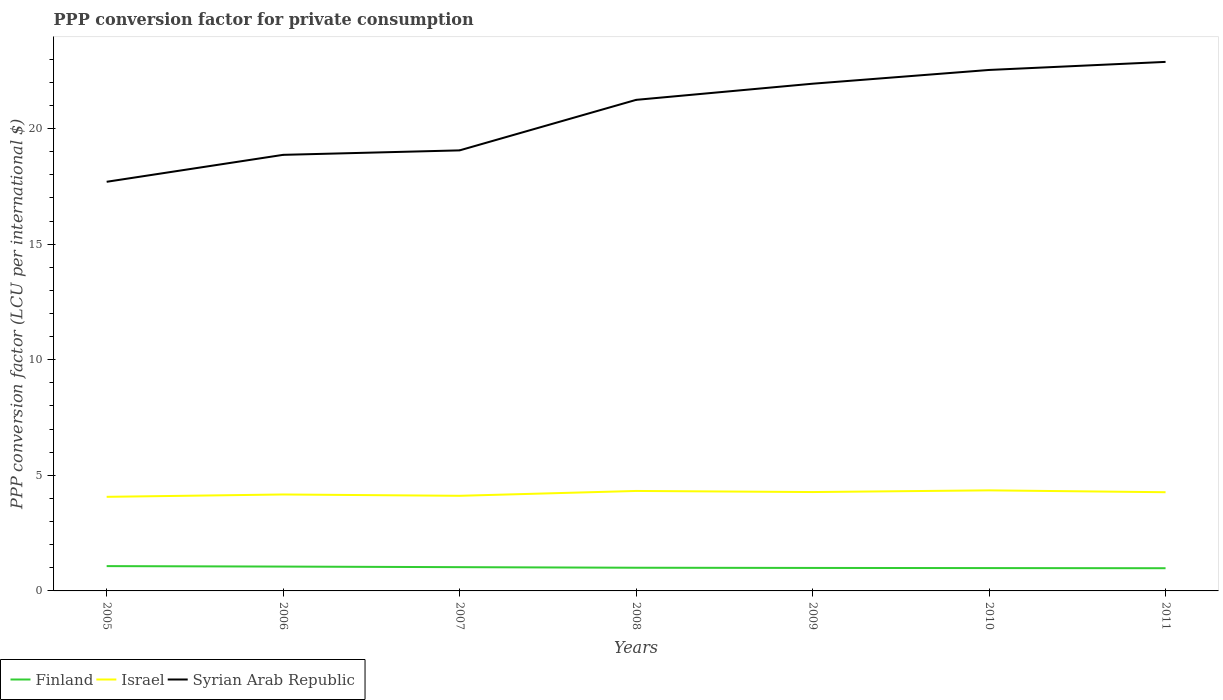Is the number of lines equal to the number of legend labels?
Your response must be concise. Yes. Across all years, what is the maximum PPP conversion factor for private consumption in Israel?
Offer a terse response. 4.07. What is the total PPP conversion factor for private consumption in Syrian Arab Republic in the graph?
Offer a terse response. -4.84. What is the difference between the highest and the second highest PPP conversion factor for private consumption in Israel?
Give a very brief answer. 0.28. How many lines are there?
Provide a succinct answer. 3. How many years are there in the graph?
Provide a succinct answer. 7. Does the graph contain any zero values?
Your answer should be very brief. No. How are the legend labels stacked?
Your answer should be very brief. Horizontal. What is the title of the graph?
Offer a very short reply. PPP conversion factor for private consumption. Does "Antigua and Barbuda" appear as one of the legend labels in the graph?
Give a very brief answer. No. What is the label or title of the X-axis?
Give a very brief answer. Years. What is the label or title of the Y-axis?
Provide a succinct answer. PPP conversion factor (LCU per international $). What is the PPP conversion factor (LCU per international $) in Finland in 2005?
Your response must be concise. 1.07. What is the PPP conversion factor (LCU per international $) of Israel in 2005?
Give a very brief answer. 4.07. What is the PPP conversion factor (LCU per international $) in Syrian Arab Republic in 2005?
Keep it short and to the point. 17.7. What is the PPP conversion factor (LCU per international $) in Finland in 2006?
Your response must be concise. 1.05. What is the PPP conversion factor (LCU per international $) in Israel in 2006?
Give a very brief answer. 4.17. What is the PPP conversion factor (LCU per international $) in Syrian Arab Republic in 2006?
Make the answer very short. 18.87. What is the PPP conversion factor (LCU per international $) of Finland in 2007?
Make the answer very short. 1.03. What is the PPP conversion factor (LCU per international $) of Israel in 2007?
Offer a terse response. 4.12. What is the PPP conversion factor (LCU per international $) of Syrian Arab Republic in 2007?
Provide a succinct answer. 19.06. What is the PPP conversion factor (LCU per international $) of Finland in 2008?
Keep it short and to the point. 1. What is the PPP conversion factor (LCU per international $) in Israel in 2008?
Your answer should be compact. 4.32. What is the PPP conversion factor (LCU per international $) of Syrian Arab Republic in 2008?
Provide a succinct answer. 21.24. What is the PPP conversion factor (LCU per international $) in Finland in 2009?
Provide a succinct answer. 0.99. What is the PPP conversion factor (LCU per international $) in Israel in 2009?
Offer a very short reply. 4.28. What is the PPP conversion factor (LCU per international $) in Syrian Arab Republic in 2009?
Provide a succinct answer. 21.94. What is the PPP conversion factor (LCU per international $) in Finland in 2010?
Ensure brevity in your answer.  0.99. What is the PPP conversion factor (LCU per international $) in Israel in 2010?
Provide a short and direct response. 4.35. What is the PPP conversion factor (LCU per international $) of Syrian Arab Republic in 2010?
Ensure brevity in your answer.  22.54. What is the PPP conversion factor (LCU per international $) in Finland in 2011?
Give a very brief answer. 0.98. What is the PPP conversion factor (LCU per international $) of Israel in 2011?
Offer a terse response. 4.27. What is the PPP conversion factor (LCU per international $) of Syrian Arab Republic in 2011?
Your answer should be very brief. 22.89. Across all years, what is the maximum PPP conversion factor (LCU per international $) in Finland?
Ensure brevity in your answer.  1.07. Across all years, what is the maximum PPP conversion factor (LCU per international $) in Israel?
Offer a terse response. 4.35. Across all years, what is the maximum PPP conversion factor (LCU per international $) in Syrian Arab Republic?
Your answer should be compact. 22.89. Across all years, what is the minimum PPP conversion factor (LCU per international $) in Finland?
Your response must be concise. 0.98. Across all years, what is the minimum PPP conversion factor (LCU per international $) in Israel?
Ensure brevity in your answer.  4.07. Across all years, what is the minimum PPP conversion factor (LCU per international $) of Syrian Arab Republic?
Keep it short and to the point. 17.7. What is the total PPP conversion factor (LCU per international $) of Finland in the graph?
Your answer should be compact. 7.12. What is the total PPP conversion factor (LCU per international $) in Israel in the graph?
Keep it short and to the point. 29.58. What is the total PPP conversion factor (LCU per international $) of Syrian Arab Republic in the graph?
Offer a terse response. 144.23. What is the difference between the PPP conversion factor (LCU per international $) in Finland in 2005 and that in 2006?
Provide a succinct answer. 0.02. What is the difference between the PPP conversion factor (LCU per international $) of Israel in 2005 and that in 2006?
Make the answer very short. -0.1. What is the difference between the PPP conversion factor (LCU per international $) in Syrian Arab Republic in 2005 and that in 2006?
Ensure brevity in your answer.  -1.17. What is the difference between the PPP conversion factor (LCU per international $) of Finland in 2005 and that in 2007?
Provide a succinct answer. 0.05. What is the difference between the PPP conversion factor (LCU per international $) in Israel in 2005 and that in 2007?
Give a very brief answer. -0.04. What is the difference between the PPP conversion factor (LCU per international $) in Syrian Arab Republic in 2005 and that in 2007?
Ensure brevity in your answer.  -1.36. What is the difference between the PPP conversion factor (LCU per international $) of Finland in 2005 and that in 2008?
Provide a short and direct response. 0.07. What is the difference between the PPP conversion factor (LCU per international $) of Israel in 2005 and that in 2008?
Give a very brief answer. -0.25. What is the difference between the PPP conversion factor (LCU per international $) of Syrian Arab Republic in 2005 and that in 2008?
Offer a terse response. -3.54. What is the difference between the PPP conversion factor (LCU per international $) of Finland in 2005 and that in 2009?
Provide a succinct answer. 0.08. What is the difference between the PPP conversion factor (LCU per international $) in Israel in 2005 and that in 2009?
Keep it short and to the point. -0.21. What is the difference between the PPP conversion factor (LCU per international $) of Syrian Arab Republic in 2005 and that in 2009?
Provide a short and direct response. -4.24. What is the difference between the PPP conversion factor (LCU per international $) of Finland in 2005 and that in 2010?
Offer a terse response. 0.09. What is the difference between the PPP conversion factor (LCU per international $) of Israel in 2005 and that in 2010?
Ensure brevity in your answer.  -0.28. What is the difference between the PPP conversion factor (LCU per international $) of Syrian Arab Republic in 2005 and that in 2010?
Your answer should be very brief. -4.84. What is the difference between the PPP conversion factor (LCU per international $) in Finland in 2005 and that in 2011?
Your answer should be compact. 0.09. What is the difference between the PPP conversion factor (LCU per international $) of Israel in 2005 and that in 2011?
Make the answer very short. -0.2. What is the difference between the PPP conversion factor (LCU per international $) of Syrian Arab Republic in 2005 and that in 2011?
Make the answer very short. -5.19. What is the difference between the PPP conversion factor (LCU per international $) of Finland in 2006 and that in 2007?
Ensure brevity in your answer.  0.03. What is the difference between the PPP conversion factor (LCU per international $) in Israel in 2006 and that in 2007?
Your answer should be very brief. 0.06. What is the difference between the PPP conversion factor (LCU per international $) of Syrian Arab Republic in 2006 and that in 2007?
Offer a very short reply. -0.19. What is the difference between the PPP conversion factor (LCU per international $) of Finland in 2006 and that in 2008?
Ensure brevity in your answer.  0.05. What is the difference between the PPP conversion factor (LCU per international $) of Israel in 2006 and that in 2008?
Your response must be concise. -0.15. What is the difference between the PPP conversion factor (LCU per international $) in Syrian Arab Republic in 2006 and that in 2008?
Give a very brief answer. -2.38. What is the difference between the PPP conversion factor (LCU per international $) of Finland in 2006 and that in 2009?
Make the answer very short. 0.06. What is the difference between the PPP conversion factor (LCU per international $) in Israel in 2006 and that in 2009?
Offer a very short reply. -0.1. What is the difference between the PPP conversion factor (LCU per international $) of Syrian Arab Republic in 2006 and that in 2009?
Make the answer very short. -3.08. What is the difference between the PPP conversion factor (LCU per international $) of Finland in 2006 and that in 2010?
Your answer should be compact. 0.07. What is the difference between the PPP conversion factor (LCU per international $) of Israel in 2006 and that in 2010?
Your answer should be very brief. -0.18. What is the difference between the PPP conversion factor (LCU per international $) of Syrian Arab Republic in 2006 and that in 2010?
Your answer should be compact. -3.67. What is the difference between the PPP conversion factor (LCU per international $) in Finland in 2006 and that in 2011?
Provide a succinct answer. 0.07. What is the difference between the PPP conversion factor (LCU per international $) in Israel in 2006 and that in 2011?
Offer a very short reply. -0.1. What is the difference between the PPP conversion factor (LCU per international $) of Syrian Arab Republic in 2006 and that in 2011?
Provide a succinct answer. -4.02. What is the difference between the PPP conversion factor (LCU per international $) in Finland in 2007 and that in 2008?
Give a very brief answer. 0.03. What is the difference between the PPP conversion factor (LCU per international $) in Israel in 2007 and that in 2008?
Keep it short and to the point. -0.21. What is the difference between the PPP conversion factor (LCU per international $) in Syrian Arab Republic in 2007 and that in 2008?
Your answer should be compact. -2.19. What is the difference between the PPP conversion factor (LCU per international $) of Finland in 2007 and that in 2009?
Offer a very short reply. 0.03. What is the difference between the PPP conversion factor (LCU per international $) in Israel in 2007 and that in 2009?
Your response must be concise. -0.16. What is the difference between the PPP conversion factor (LCU per international $) in Syrian Arab Republic in 2007 and that in 2009?
Ensure brevity in your answer.  -2.88. What is the difference between the PPP conversion factor (LCU per international $) in Finland in 2007 and that in 2010?
Your answer should be compact. 0.04. What is the difference between the PPP conversion factor (LCU per international $) in Israel in 2007 and that in 2010?
Offer a terse response. -0.24. What is the difference between the PPP conversion factor (LCU per international $) in Syrian Arab Republic in 2007 and that in 2010?
Your answer should be very brief. -3.48. What is the difference between the PPP conversion factor (LCU per international $) of Finland in 2007 and that in 2011?
Offer a terse response. 0.05. What is the difference between the PPP conversion factor (LCU per international $) of Israel in 2007 and that in 2011?
Your response must be concise. -0.16. What is the difference between the PPP conversion factor (LCU per international $) in Syrian Arab Republic in 2007 and that in 2011?
Offer a terse response. -3.83. What is the difference between the PPP conversion factor (LCU per international $) in Finland in 2008 and that in 2009?
Your response must be concise. 0.01. What is the difference between the PPP conversion factor (LCU per international $) of Israel in 2008 and that in 2009?
Give a very brief answer. 0.05. What is the difference between the PPP conversion factor (LCU per international $) of Syrian Arab Republic in 2008 and that in 2009?
Offer a very short reply. -0.7. What is the difference between the PPP conversion factor (LCU per international $) of Finland in 2008 and that in 2010?
Offer a very short reply. 0.01. What is the difference between the PPP conversion factor (LCU per international $) of Israel in 2008 and that in 2010?
Your answer should be compact. -0.03. What is the difference between the PPP conversion factor (LCU per international $) in Syrian Arab Republic in 2008 and that in 2010?
Offer a terse response. -1.29. What is the difference between the PPP conversion factor (LCU per international $) in Finland in 2008 and that in 2011?
Your answer should be very brief. 0.02. What is the difference between the PPP conversion factor (LCU per international $) of Israel in 2008 and that in 2011?
Your answer should be compact. 0.05. What is the difference between the PPP conversion factor (LCU per international $) in Syrian Arab Republic in 2008 and that in 2011?
Provide a succinct answer. -1.64. What is the difference between the PPP conversion factor (LCU per international $) of Finland in 2009 and that in 2010?
Make the answer very short. 0.01. What is the difference between the PPP conversion factor (LCU per international $) in Israel in 2009 and that in 2010?
Offer a very short reply. -0.07. What is the difference between the PPP conversion factor (LCU per international $) of Syrian Arab Republic in 2009 and that in 2010?
Your answer should be very brief. -0.6. What is the difference between the PPP conversion factor (LCU per international $) in Finland in 2009 and that in 2011?
Make the answer very short. 0.01. What is the difference between the PPP conversion factor (LCU per international $) in Israel in 2009 and that in 2011?
Offer a very short reply. 0.01. What is the difference between the PPP conversion factor (LCU per international $) of Syrian Arab Republic in 2009 and that in 2011?
Your response must be concise. -0.94. What is the difference between the PPP conversion factor (LCU per international $) in Finland in 2010 and that in 2011?
Provide a succinct answer. 0.01. What is the difference between the PPP conversion factor (LCU per international $) in Israel in 2010 and that in 2011?
Ensure brevity in your answer.  0.08. What is the difference between the PPP conversion factor (LCU per international $) of Syrian Arab Republic in 2010 and that in 2011?
Keep it short and to the point. -0.35. What is the difference between the PPP conversion factor (LCU per international $) of Finland in 2005 and the PPP conversion factor (LCU per international $) of Israel in 2006?
Give a very brief answer. -3.1. What is the difference between the PPP conversion factor (LCU per international $) in Finland in 2005 and the PPP conversion factor (LCU per international $) in Syrian Arab Republic in 2006?
Provide a short and direct response. -17.79. What is the difference between the PPP conversion factor (LCU per international $) in Israel in 2005 and the PPP conversion factor (LCU per international $) in Syrian Arab Republic in 2006?
Your answer should be very brief. -14.79. What is the difference between the PPP conversion factor (LCU per international $) of Finland in 2005 and the PPP conversion factor (LCU per international $) of Israel in 2007?
Give a very brief answer. -3.04. What is the difference between the PPP conversion factor (LCU per international $) in Finland in 2005 and the PPP conversion factor (LCU per international $) in Syrian Arab Republic in 2007?
Ensure brevity in your answer.  -17.99. What is the difference between the PPP conversion factor (LCU per international $) in Israel in 2005 and the PPP conversion factor (LCU per international $) in Syrian Arab Republic in 2007?
Your answer should be compact. -14.99. What is the difference between the PPP conversion factor (LCU per international $) of Finland in 2005 and the PPP conversion factor (LCU per international $) of Israel in 2008?
Your answer should be very brief. -3.25. What is the difference between the PPP conversion factor (LCU per international $) of Finland in 2005 and the PPP conversion factor (LCU per international $) of Syrian Arab Republic in 2008?
Your response must be concise. -20.17. What is the difference between the PPP conversion factor (LCU per international $) of Israel in 2005 and the PPP conversion factor (LCU per international $) of Syrian Arab Republic in 2008?
Ensure brevity in your answer.  -17.17. What is the difference between the PPP conversion factor (LCU per international $) in Finland in 2005 and the PPP conversion factor (LCU per international $) in Israel in 2009?
Provide a succinct answer. -3.2. What is the difference between the PPP conversion factor (LCU per international $) in Finland in 2005 and the PPP conversion factor (LCU per international $) in Syrian Arab Republic in 2009?
Your response must be concise. -20.87. What is the difference between the PPP conversion factor (LCU per international $) in Israel in 2005 and the PPP conversion factor (LCU per international $) in Syrian Arab Republic in 2009?
Give a very brief answer. -17.87. What is the difference between the PPP conversion factor (LCU per international $) in Finland in 2005 and the PPP conversion factor (LCU per international $) in Israel in 2010?
Ensure brevity in your answer.  -3.28. What is the difference between the PPP conversion factor (LCU per international $) in Finland in 2005 and the PPP conversion factor (LCU per international $) in Syrian Arab Republic in 2010?
Ensure brevity in your answer.  -21.46. What is the difference between the PPP conversion factor (LCU per international $) of Israel in 2005 and the PPP conversion factor (LCU per international $) of Syrian Arab Republic in 2010?
Keep it short and to the point. -18.47. What is the difference between the PPP conversion factor (LCU per international $) in Finland in 2005 and the PPP conversion factor (LCU per international $) in Israel in 2011?
Provide a succinct answer. -3.2. What is the difference between the PPP conversion factor (LCU per international $) of Finland in 2005 and the PPP conversion factor (LCU per international $) of Syrian Arab Republic in 2011?
Provide a succinct answer. -21.81. What is the difference between the PPP conversion factor (LCU per international $) of Israel in 2005 and the PPP conversion factor (LCU per international $) of Syrian Arab Republic in 2011?
Offer a terse response. -18.82. What is the difference between the PPP conversion factor (LCU per international $) in Finland in 2006 and the PPP conversion factor (LCU per international $) in Israel in 2007?
Give a very brief answer. -3.06. What is the difference between the PPP conversion factor (LCU per international $) of Finland in 2006 and the PPP conversion factor (LCU per international $) of Syrian Arab Republic in 2007?
Ensure brevity in your answer.  -18.01. What is the difference between the PPP conversion factor (LCU per international $) of Israel in 2006 and the PPP conversion factor (LCU per international $) of Syrian Arab Republic in 2007?
Give a very brief answer. -14.89. What is the difference between the PPP conversion factor (LCU per international $) in Finland in 2006 and the PPP conversion factor (LCU per international $) in Israel in 2008?
Keep it short and to the point. -3.27. What is the difference between the PPP conversion factor (LCU per international $) in Finland in 2006 and the PPP conversion factor (LCU per international $) in Syrian Arab Republic in 2008?
Provide a succinct answer. -20.19. What is the difference between the PPP conversion factor (LCU per international $) in Israel in 2006 and the PPP conversion factor (LCU per international $) in Syrian Arab Republic in 2008?
Offer a very short reply. -17.07. What is the difference between the PPP conversion factor (LCU per international $) in Finland in 2006 and the PPP conversion factor (LCU per international $) in Israel in 2009?
Keep it short and to the point. -3.22. What is the difference between the PPP conversion factor (LCU per international $) in Finland in 2006 and the PPP conversion factor (LCU per international $) in Syrian Arab Republic in 2009?
Offer a terse response. -20.89. What is the difference between the PPP conversion factor (LCU per international $) of Israel in 2006 and the PPP conversion factor (LCU per international $) of Syrian Arab Republic in 2009?
Make the answer very short. -17.77. What is the difference between the PPP conversion factor (LCU per international $) in Finland in 2006 and the PPP conversion factor (LCU per international $) in Israel in 2010?
Ensure brevity in your answer.  -3.3. What is the difference between the PPP conversion factor (LCU per international $) of Finland in 2006 and the PPP conversion factor (LCU per international $) of Syrian Arab Republic in 2010?
Keep it short and to the point. -21.48. What is the difference between the PPP conversion factor (LCU per international $) in Israel in 2006 and the PPP conversion factor (LCU per international $) in Syrian Arab Republic in 2010?
Provide a succinct answer. -18.37. What is the difference between the PPP conversion factor (LCU per international $) of Finland in 2006 and the PPP conversion factor (LCU per international $) of Israel in 2011?
Offer a very short reply. -3.22. What is the difference between the PPP conversion factor (LCU per international $) of Finland in 2006 and the PPP conversion factor (LCU per international $) of Syrian Arab Republic in 2011?
Ensure brevity in your answer.  -21.83. What is the difference between the PPP conversion factor (LCU per international $) in Israel in 2006 and the PPP conversion factor (LCU per international $) in Syrian Arab Republic in 2011?
Your answer should be compact. -18.71. What is the difference between the PPP conversion factor (LCU per international $) in Finland in 2007 and the PPP conversion factor (LCU per international $) in Israel in 2008?
Provide a succinct answer. -3.3. What is the difference between the PPP conversion factor (LCU per international $) in Finland in 2007 and the PPP conversion factor (LCU per international $) in Syrian Arab Republic in 2008?
Provide a short and direct response. -20.22. What is the difference between the PPP conversion factor (LCU per international $) in Israel in 2007 and the PPP conversion factor (LCU per international $) in Syrian Arab Republic in 2008?
Give a very brief answer. -17.13. What is the difference between the PPP conversion factor (LCU per international $) of Finland in 2007 and the PPP conversion factor (LCU per international $) of Israel in 2009?
Provide a short and direct response. -3.25. What is the difference between the PPP conversion factor (LCU per international $) in Finland in 2007 and the PPP conversion factor (LCU per international $) in Syrian Arab Republic in 2009?
Offer a very short reply. -20.91. What is the difference between the PPP conversion factor (LCU per international $) of Israel in 2007 and the PPP conversion factor (LCU per international $) of Syrian Arab Republic in 2009?
Keep it short and to the point. -17.83. What is the difference between the PPP conversion factor (LCU per international $) in Finland in 2007 and the PPP conversion factor (LCU per international $) in Israel in 2010?
Give a very brief answer. -3.32. What is the difference between the PPP conversion factor (LCU per international $) in Finland in 2007 and the PPP conversion factor (LCU per international $) in Syrian Arab Republic in 2010?
Keep it short and to the point. -21.51. What is the difference between the PPP conversion factor (LCU per international $) of Israel in 2007 and the PPP conversion factor (LCU per international $) of Syrian Arab Republic in 2010?
Offer a very short reply. -18.42. What is the difference between the PPP conversion factor (LCU per international $) in Finland in 2007 and the PPP conversion factor (LCU per international $) in Israel in 2011?
Provide a short and direct response. -3.24. What is the difference between the PPP conversion factor (LCU per international $) in Finland in 2007 and the PPP conversion factor (LCU per international $) in Syrian Arab Republic in 2011?
Your answer should be very brief. -21.86. What is the difference between the PPP conversion factor (LCU per international $) in Israel in 2007 and the PPP conversion factor (LCU per international $) in Syrian Arab Republic in 2011?
Offer a terse response. -18.77. What is the difference between the PPP conversion factor (LCU per international $) in Finland in 2008 and the PPP conversion factor (LCU per international $) in Israel in 2009?
Keep it short and to the point. -3.27. What is the difference between the PPP conversion factor (LCU per international $) of Finland in 2008 and the PPP conversion factor (LCU per international $) of Syrian Arab Republic in 2009?
Ensure brevity in your answer.  -20.94. What is the difference between the PPP conversion factor (LCU per international $) in Israel in 2008 and the PPP conversion factor (LCU per international $) in Syrian Arab Republic in 2009?
Provide a short and direct response. -17.62. What is the difference between the PPP conversion factor (LCU per international $) in Finland in 2008 and the PPP conversion factor (LCU per international $) in Israel in 2010?
Your response must be concise. -3.35. What is the difference between the PPP conversion factor (LCU per international $) in Finland in 2008 and the PPP conversion factor (LCU per international $) in Syrian Arab Republic in 2010?
Your answer should be very brief. -21.54. What is the difference between the PPP conversion factor (LCU per international $) in Israel in 2008 and the PPP conversion factor (LCU per international $) in Syrian Arab Republic in 2010?
Your answer should be compact. -18.21. What is the difference between the PPP conversion factor (LCU per international $) of Finland in 2008 and the PPP conversion factor (LCU per international $) of Israel in 2011?
Provide a succinct answer. -3.27. What is the difference between the PPP conversion factor (LCU per international $) in Finland in 2008 and the PPP conversion factor (LCU per international $) in Syrian Arab Republic in 2011?
Offer a very short reply. -21.88. What is the difference between the PPP conversion factor (LCU per international $) of Israel in 2008 and the PPP conversion factor (LCU per international $) of Syrian Arab Republic in 2011?
Your answer should be compact. -18.56. What is the difference between the PPP conversion factor (LCU per international $) of Finland in 2009 and the PPP conversion factor (LCU per international $) of Israel in 2010?
Ensure brevity in your answer.  -3.36. What is the difference between the PPP conversion factor (LCU per international $) in Finland in 2009 and the PPP conversion factor (LCU per international $) in Syrian Arab Republic in 2010?
Provide a succinct answer. -21.54. What is the difference between the PPP conversion factor (LCU per international $) of Israel in 2009 and the PPP conversion factor (LCU per international $) of Syrian Arab Republic in 2010?
Make the answer very short. -18.26. What is the difference between the PPP conversion factor (LCU per international $) of Finland in 2009 and the PPP conversion factor (LCU per international $) of Israel in 2011?
Offer a very short reply. -3.28. What is the difference between the PPP conversion factor (LCU per international $) in Finland in 2009 and the PPP conversion factor (LCU per international $) in Syrian Arab Republic in 2011?
Provide a short and direct response. -21.89. What is the difference between the PPP conversion factor (LCU per international $) of Israel in 2009 and the PPP conversion factor (LCU per international $) of Syrian Arab Republic in 2011?
Make the answer very short. -18.61. What is the difference between the PPP conversion factor (LCU per international $) of Finland in 2010 and the PPP conversion factor (LCU per international $) of Israel in 2011?
Your answer should be very brief. -3.28. What is the difference between the PPP conversion factor (LCU per international $) in Finland in 2010 and the PPP conversion factor (LCU per international $) in Syrian Arab Republic in 2011?
Your answer should be very brief. -21.9. What is the difference between the PPP conversion factor (LCU per international $) of Israel in 2010 and the PPP conversion factor (LCU per international $) of Syrian Arab Republic in 2011?
Give a very brief answer. -18.54. What is the average PPP conversion factor (LCU per international $) in Finland per year?
Provide a succinct answer. 1.02. What is the average PPP conversion factor (LCU per international $) in Israel per year?
Offer a very short reply. 4.23. What is the average PPP conversion factor (LCU per international $) in Syrian Arab Republic per year?
Provide a short and direct response. 20.6. In the year 2005, what is the difference between the PPP conversion factor (LCU per international $) in Finland and PPP conversion factor (LCU per international $) in Israel?
Keep it short and to the point. -3. In the year 2005, what is the difference between the PPP conversion factor (LCU per international $) in Finland and PPP conversion factor (LCU per international $) in Syrian Arab Republic?
Provide a short and direct response. -16.63. In the year 2005, what is the difference between the PPP conversion factor (LCU per international $) in Israel and PPP conversion factor (LCU per international $) in Syrian Arab Republic?
Offer a terse response. -13.63. In the year 2006, what is the difference between the PPP conversion factor (LCU per international $) in Finland and PPP conversion factor (LCU per international $) in Israel?
Ensure brevity in your answer.  -3.12. In the year 2006, what is the difference between the PPP conversion factor (LCU per international $) in Finland and PPP conversion factor (LCU per international $) in Syrian Arab Republic?
Make the answer very short. -17.81. In the year 2006, what is the difference between the PPP conversion factor (LCU per international $) of Israel and PPP conversion factor (LCU per international $) of Syrian Arab Republic?
Offer a very short reply. -14.69. In the year 2007, what is the difference between the PPP conversion factor (LCU per international $) in Finland and PPP conversion factor (LCU per international $) in Israel?
Make the answer very short. -3.09. In the year 2007, what is the difference between the PPP conversion factor (LCU per international $) of Finland and PPP conversion factor (LCU per international $) of Syrian Arab Republic?
Make the answer very short. -18.03. In the year 2007, what is the difference between the PPP conversion factor (LCU per international $) of Israel and PPP conversion factor (LCU per international $) of Syrian Arab Republic?
Give a very brief answer. -14.94. In the year 2008, what is the difference between the PPP conversion factor (LCU per international $) in Finland and PPP conversion factor (LCU per international $) in Israel?
Give a very brief answer. -3.32. In the year 2008, what is the difference between the PPP conversion factor (LCU per international $) of Finland and PPP conversion factor (LCU per international $) of Syrian Arab Republic?
Offer a very short reply. -20.24. In the year 2008, what is the difference between the PPP conversion factor (LCU per international $) in Israel and PPP conversion factor (LCU per international $) in Syrian Arab Republic?
Your answer should be compact. -16.92. In the year 2009, what is the difference between the PPP conversion factor (LCU per international $) in Finland and PPP conversion factor (LCU per international $) in Israel?
Ensure brevity in your answer.  -3.28. In the year 2009, what is the difference between the PPP conversion factor (LCU per international $) of Finland and PPP conversion factor (LCU per international $) of Syrian Arab Republic?
Offer a terse response. -20.95. In the year 2009, what is the difference between the PPP conversion factor (LCU per international $) of Israel and PPP conversion factor (LCU per international $) of Syrian Arab Republic?
Your answer should be compact. -17.67. In the year 2010, what is the difference between the PPP conversion factor (LCU per international $) in Finland and PPP conversion factor (LCU per international $) in Israel?
Your response must be concise. -3.36. In the year 2010, what is the difference between the PPP conversion factor (LCU per international $) in Finland and PPP conversion factor (LCU per international $) in Syrian Arab Republic?
Offer a terse response. -21.55. In the year 2010, what is the difference between the PPP conversion factor (LCU per international $) in Israel and PPP conversion factor (LCU per international $) in Syrian Arab Republic?
Provide a succinct answer. -18.19. In the year 2011, what is the difference between the PPP conversion factor (LCU per international $) in Finland and PPP conversion factor (LCU per international $) in Israel?
Your response must be concise. -3.29. In the year 2011, what is the difference between the PPP conversion factor (LCU per international $) of Finland and PPP conversion factor (LCU per international $) of Syrian Arab Republic?
Provide a succinct answer. -21.9. In the year 2011, what is the difference between the PPP conversion factor (LCU per international $) of Israel and PPP conversion factor (LCU per international $) of Syrian Arab Republic?
Your answer should be compact. -18.62. What is the ratio of the PPP conversion factor (LCU per international $) in Finland in 2005 to that in 2006?
Keep it short and to the point. 1.02. What is the ratio of the PPP conversion factor (LCU per international $) of Israel in 2005 to that in 2006?
Your answer should be very brief. 0.98. What is the ratio of the PPP conversion factor (LCU per international $) in Syrian Arab Republic in 2005 to that in 2006?
Ensure brevity in your answer.  0.94. What is the ratio of the PPP conversion factor (LCU per international $) of Finland in 2005 to that in 2007?
Make the answer very short. 1.04. What is the ratio of the PPP conversion factor (LCU per international $) in Israel in 2005 to that in 2007?
Provide a short and direct response. 0.99. What is the ratio of the PPP conversion factor (LCU per international $) in Syrian Arab Republic in 2005 to that in 2007?
Ensure brevity in your answer.  0.93. What is the ratio of the PPP conversion factor (LCU per international $) in Finland in 2005 to that in 2008?
Offer a terse response. 1.07. What is the ratio of the PPP conversion factor (LCU per international $) in Israel in 2005 to that in 2008?
Provide a succinct answer. 0.94. What is the ratio of the PPP conversion factor (LCU per international $) of Syrian Arab Republic in 2005 to that in 2008?
Your response must be concise. 0.83. What is the ratio of the PPP conversion factor (LCU per international $) in Finland in 2005 to that in 2009?
Provide a succinct answer. 1.08. What is the ratio of the PPP conversion factor (LCU per international $) of Israel in 2005 to that in 2009?
Give a very brief answer. 0.95. What is the ratio of the PPP conversion factor (LCU per international $) of Syrian Arab Republic in 2005 to that in 2009?
Offer a terse response. 0.81. What is the ratio of the PPP conversion factor (LCU per international $) of Finland in 2005 to that in 2010?
Provide a succinct answer. 1.09. What is the ratio of the PPP conversion factor (LCU per international $) in Israel in 2005 to that in 2010?
Your answer should be very brief. 0.94. What is the ratio of the PPP conversion factor (LCU per international $) of Syrian Arab Republic in 2005 to that in 2010?
Your answer should be very brief. 0.79. What is the ratio of the PPP conversion factor (LCU per international $) in Finland in 2005 to that in 2011?
Offer a very short reply. 1.09. What is the ratio of the PPP conversion factor (LCU per international $) of Israel in 2005 to that in 2011?
Offer a terse response. 0.95. What is the ratio of the PPP conversion factor (LCU per international $) in Syrian Arab Republic in 2005 to that in 2011?
Keep it short and to the point. 0.77. What is the ratio of the PPP conversion factor (LCU per international $) of Finland in 2006 to that in 2007?
Provide a succinct answer. 1.02. What is the ratio of the PPP conversion factor (LCU per international $) of Israel in 2006 to that in 2007?
Your answer should be very brief. 1.01. What is the ratio of the PPP conversion factor (LCU per international $) of Finland in 2006 to that in 2008?
Give a very brief answer. 1.05. What is the ratio of the PPP conversion factor (LCU per international $) in Israel in 2006 to that in 2008?
Provide a short and direct response. 0.96. What is the ratio of the PPP conversion factor (LCU per international $) in Syrian Arab Republic in 2006 to that in 2008?
Your answer should be compact. 0.89. What is the ratio of the PPP conversion factor (LCU per international $) of Finland in 2006 to that in 2009?
Offer a very short reply. 1.06. What is the ratio of the PPP conversion factor (LCU per international $) in Israel in 2006 to that in 2009?
Your response must be concise. 0.98. What is the ratio of the PPP conversion factor (LCU per international $) of Syrian Arab Republic in 2006 to that in 2009?
Provide a short and direct response. 0.86. What is the ratio of the PPP conversion factor (LCU per international $) of Finland in 2006 to that in 2010?
Provide a succinct answer. 1.07. What is the ratio of the PPP conversion factor (LCU per international $) of Israel in 2006 to that in 2010?
Ensure brevity in your answer.  0.96. What is the ratio of the PPP conversion factor (LCU per international $) of Syrian Arab Republic in 2006 to that in 2010?
Your answer should be compact. 0.84. What is the ratio of the PPP conversion factor (LCU per international $) of Finland in 2006 to that in 2011?
Give a very brief answer. 1.07. What is the ratio of the PPP conversion factor (LCU per international $) in Syrian Arab Republic in 2006 to that in 2011?
Keep it short and to the point. 0.82. What is the ratio of the PPP conversion factor (LCU per international $) of Finland in 2007 to that in 2008?
Provide a short and direct response. 1.03. What is the ratio of the PPP conversion factor (LCU per international $) in Israel in 2007 to that in 2008?
Offer a terse response. 0.95. What is the ratio of the PPP conversion factor (LCU per international $) in Syrian Arab Republic in 2007 to that in 2008?
Make the answer very short. 0.9. What is the ratio of the PPP conversion factor (LCU per international $) of Finland in 2007 to that in 2009?
Provide a short and direct response. 1.03. What is the ratio of the PPP conversion factor (LCU per international $) in Israel in 2007 to that in 2009?
Offer a very short reply. 0.96. What is the ratio of the PPP conversion factor (LCU per international $) in Syrian Arab Republic in 2007 to that in 2009?
Make the answer very short. 0.87. What is the ratio of the PPP conversion factor (LCU per international $) of Finland in 2007 to that in 2010?
Your answer should be compact. 1.04. What is the ratio of the PPP conversion factor (LCU per international $) of Israel in 2007 to that in 2010?
Your response must be concise. 0.95. What is the ratio of the PPP conversion factor (LCU per international $) of Syrian Arab Republic in 2007 to that in 2010?
Offer a very short reply. 0.85. What is the ratio of the PPP conversion factor (LCU per international $) in Finland in 2007 to that in 2011?
Provide a succinct answer. 1.05. What is the ratio of the PPP conversion factor (LCU per international $) of Israel in 2007 to that in 2011?
Offer a very short reply. 0.96. What is the ratio of the PPP conversion factor (LCU per international $) of Syrian Arab Republic in 2007 to that in 2011?
Ensure brevity in your answer.  0.83. What is the ratio of the PPP conversion factor (LCU per international $) in Finland in 2008 to that in 2009?
Your answer should be very brief. 1.01. What is the ratio of the PPP conversion factor (LCU per international $) of Israel in 2008 to that in 2009?
Your response must be concise. 1.01. What is the ratio of the PPP conversion factor (LCU per international $) of Syrian Arab Republic in 2008 to that in 2009?
Give a very brief answer. 0.97. What is the ratio of the PPP conversion factor (LCU per international $) of Finland in 2008 to that in 2010?
Give a very brief answer. 1.01. What is the ratio of the PPP conversion factor (LCU per international $) of Syrian Arab Republic in 2008 to that in 2010?
Your response must be concise. 0.94. What is the ratio of the PPP conversion factor (LCU per international $) in Israel in 2008 to that in 2011?
Offer a very short reply. 1.01. What is the ratio of the PPP conversion factor (LCU per international $) in Syrian Arab Republic in 2008 to that in 2011?
Your response must be concise. 0.93. What is the ratio of the PPP conversion factor (LCU per international $) in Israel in 2009 to that in 2010?
Your answer should be very brief. 0.98. What is the ratio of the PPP conversion factor (LCU per international $) in Syrian Arab Republic in 2009 to that in 2010?
Keep it short and to the point. 0.97. What is the ratio of the PPP conversion factor (LCU per international $) in Finland in 2009 to that in 2011?
Provide a succinct answer. 1.01. What is the ratio of the PPP conversion factor (LCU per international $) of Syrian Arab Republic in 2009 to that in 2011?
Your answer should be very brief. 0.96. What is the ratio of the PPP conversion factor (LCU per international $) of Israel in 2010 to that in 2011?
Make the answer very short. 1.02. What is the difference between the highest and the second highest PPP conversion factor (LCU per international $) of Israel?
Make the answer very short. 0.03. What is the difference between the highest and the second highest PPP conversion factor (LCU per international $) in Syrian Arab Republic?
Your response must be concise. 0.35. What is the difference between the highest and the lowest PPP conversion factor (LCU per international $) of Finland?
Provide a succinct answer. 0.09. What is the difference between the highest and the lowest PPP conversion factor (LCU per international $) in Israel?
Ensure brevity in your answer.  0.28. What is the difference between the highest and the lowest PPP conversion factor (LCU per international $) of Syrian Arab Republic?
Offer a terse response. 5.19. 